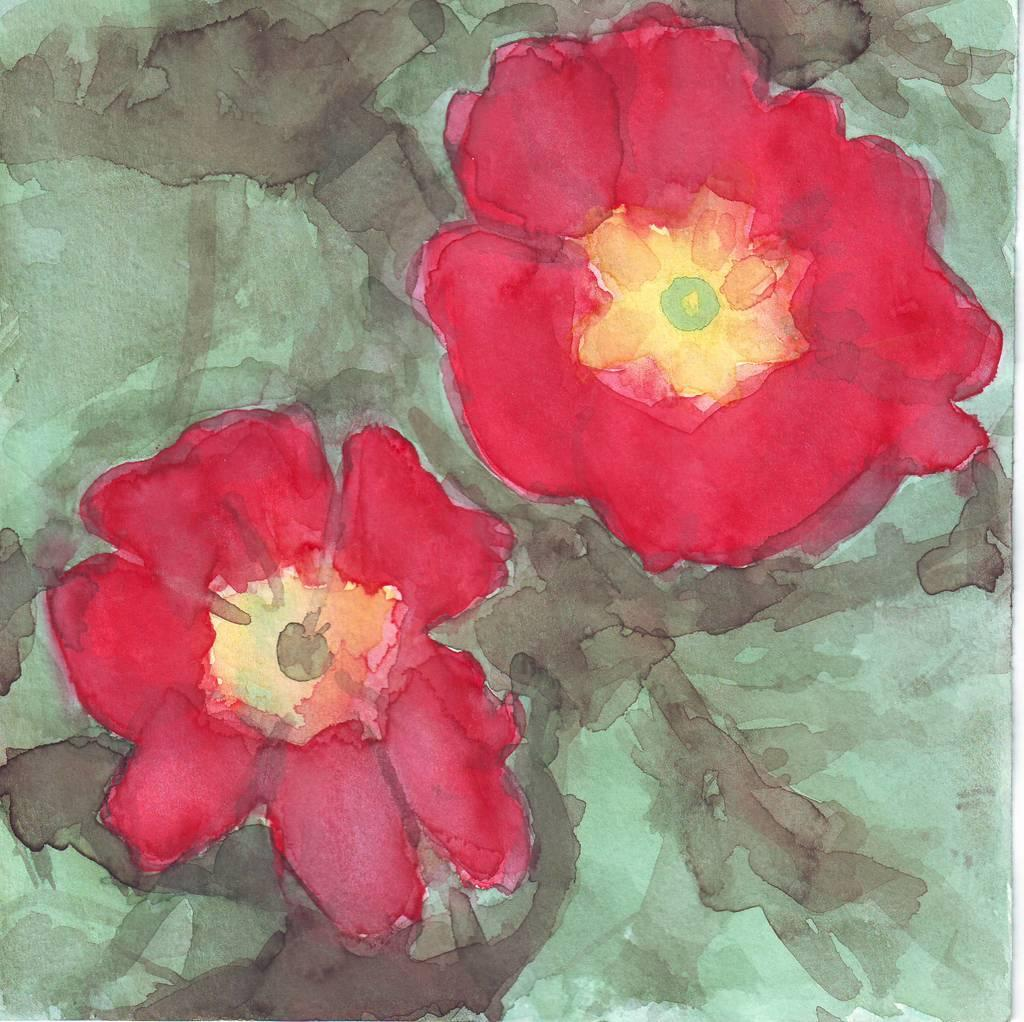What is the main subject of the image? There is a painting in the image. What is depicted in the painting? The painting depicts two red color flowers. How many flies can be seen in the painting? There are no flies depicted in the painting; it features two red color flowers. What type of pain is the artist experiencing while creating the painting? The provided facts do not mention any information about the artist or their experience while creating the painting, so we cannot determine if they are experiencing any pain. 